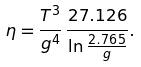<formula> <loc_0><loc_0><loc_500><loc_500>\eta = \frac { T ^ { 3 } } { g ^ { 4 } } { \, } \frac { 2 7 . 1 2 6 } { \ln \frac { 2 . 7 6 5 } { g } } .</formula> 